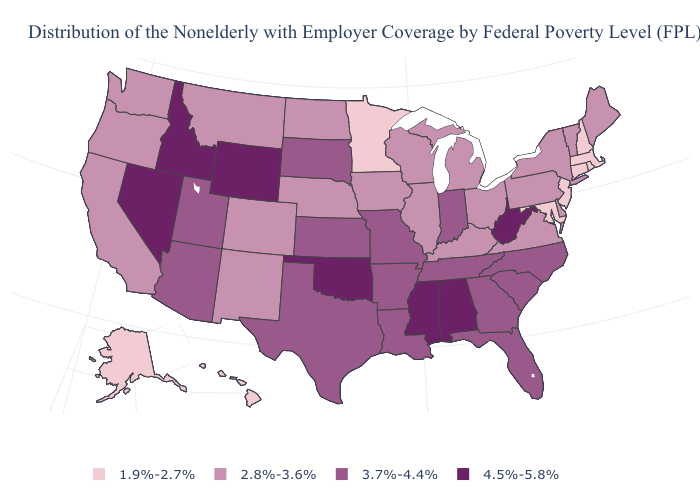Which states have the lowest value in the USA?
Short answer required. Alaska, Connecticut, Hawaii, Maryland, Massachusetts, Minnesota, New Hampshire, New Jersey, Rhode Island. What is the value of Nebraska?
Quick response, please. 2.8%-3.6%. Among the states that border North Dakota , which have the highest value?
Keep it brief. South Dakota. Which states hav the highest value in the Northeast?
Give a very brief answer. Maine, New York, Pennsylvania, Vermont. Does the first symbol in the legend represent the smallest category?
Concise answer only. Yes. What is the value of South Carolina?
Short answer required. 3.7%-4.4%. Name the states that have a value in the range 4.5%-5.8%?
Give a very brief answer. Alabama, Idaho, Mississippi, Nevada, Oklahoma, West Virginia, Wyoming. What is the value of Louisiana?
Write a very short answer. 3.7%-4.4%. What is the lowest value in the USA?
Quick response, please. 1.9%-2.7%. Which states have the highest value in the USA?
Answer briefly. Alabama, Idaho, Mississippi, Nevada, Oklahoma, West Virginia, Wyoming. Name the states that have a value in the range 1.9%-2.7%?
Quick response, please. Alaska, Connecticut, Hawaii, Maryland, Massachusetts, Minnesota, New Hampshire, New Jersey, Rhode Island. Among the states that border North Carolina , which have the lowest value?
Quick response, please. Virginia. How many symbols are there in the legend?
Answer briefly. 4. What is the value of Kentucky?
Be succinct. 2.8%-3.6%. Name the states that have a value in the range 3.7%-4.4%?
Keep it brief. Arizona, Arkansas, Florida, Georgia, Indiana, Kansas, Louisiana, Missouri, North Carolina, South Carolina, South Dakota, Tennessee, Texas, Utah. 